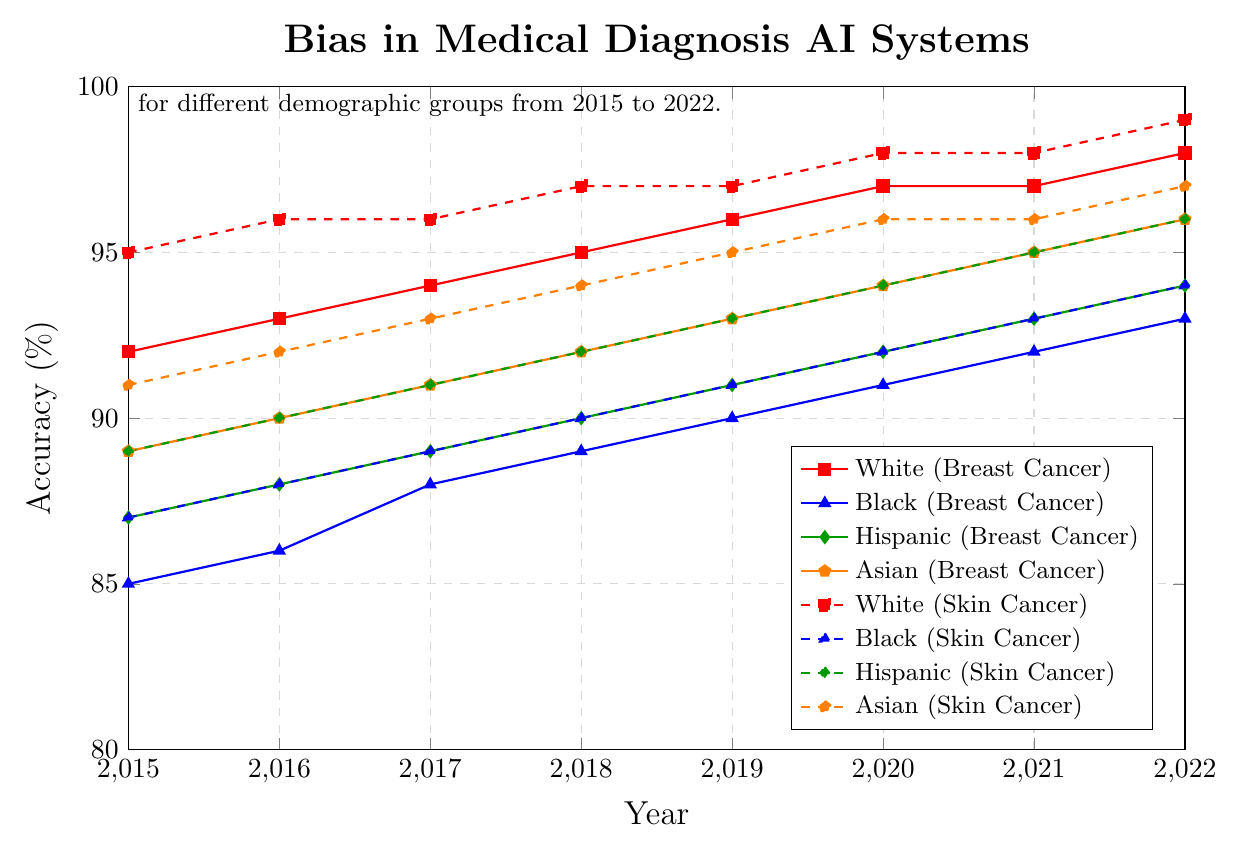What's the accuracy for 'Black' patients with Breast Cancer in 2020? Check the curve color-coded for 'Black' under 'Breast Cancer' at the year 2020 on the x-axis. The y-axis value reads 91%.
Answer: 91% Between which years did the accuracy for 'Asian' patients with Skin Cancer reach 96%? Check the dashed line for 'Asian' in the 'Skin Cancer' category. The y-axis reaches 96% between 2020 and 2021.
Answer: 2020-2021 What is the average accuracy for 'White' patients across all conditions in 2018? Add the accuracies for 'White' patients in 2018 for Breast Cancer (95), Skin Cancer (97), Cardiovascular Disease (93), and Diabetes (94). The sum is 95 + 97 + 93 + 94 = 379. The average is 379 / 4 = 94.75%.
Answer: 94.75% Which demographic group had the lowest accuracy for Cardiovascular Disease in 2017? Check the 2017 data points for 'Cardiovascular Disease' across all demographic groups. 'Black' has the lowest accuracy at 85%.
Answer: Black How much did the accuracy for 'Hispanic' patients with Diabetes increase from 2015 to 2022? The 2015 accuracy for 'Hispanic' patients with Diabetes is 86% and in 2022 it is 93%. The increase is 93 - 86 = 7%.
Answer: 7% In which year did all demographic groups show an accuracy above 90% for Breast Cancer? Find the year where the Breast Cancer accuracies for all groups ('White', 'Black', 'Hispanic', and 'Asian') are above 90%. This happens in 2020.
Answer: 2020 Which condition shows the smallest year-to-year change in accuracy for 'White' patients from 2015 to 2022? Calculate or observe the year-to-year changes for 'White' patients across all conditions. 'Skin Cancer' changes minimally, with many years showing non-significant changes.
Answer: Skin Cancer How does the accuracy for 'Asian' patients with Cardiovascular Disease compare in 2016 and 2022? Compare the 2016 (88%) and 2022 (94%) values for 'Asian' patients with Cardiovascular Disease. The accuracy has increased by 6%.
Answer: Increased by 6% What is the difference in accuracy between 'Hispanic' and 'White' patients for Diabetes in 2015? The 2015 values for 'Hispanic' and 'White' for Diabetes are 86% and 91%, respectively. The difference is 91 - 86 = 5%.
Answer: 5% 